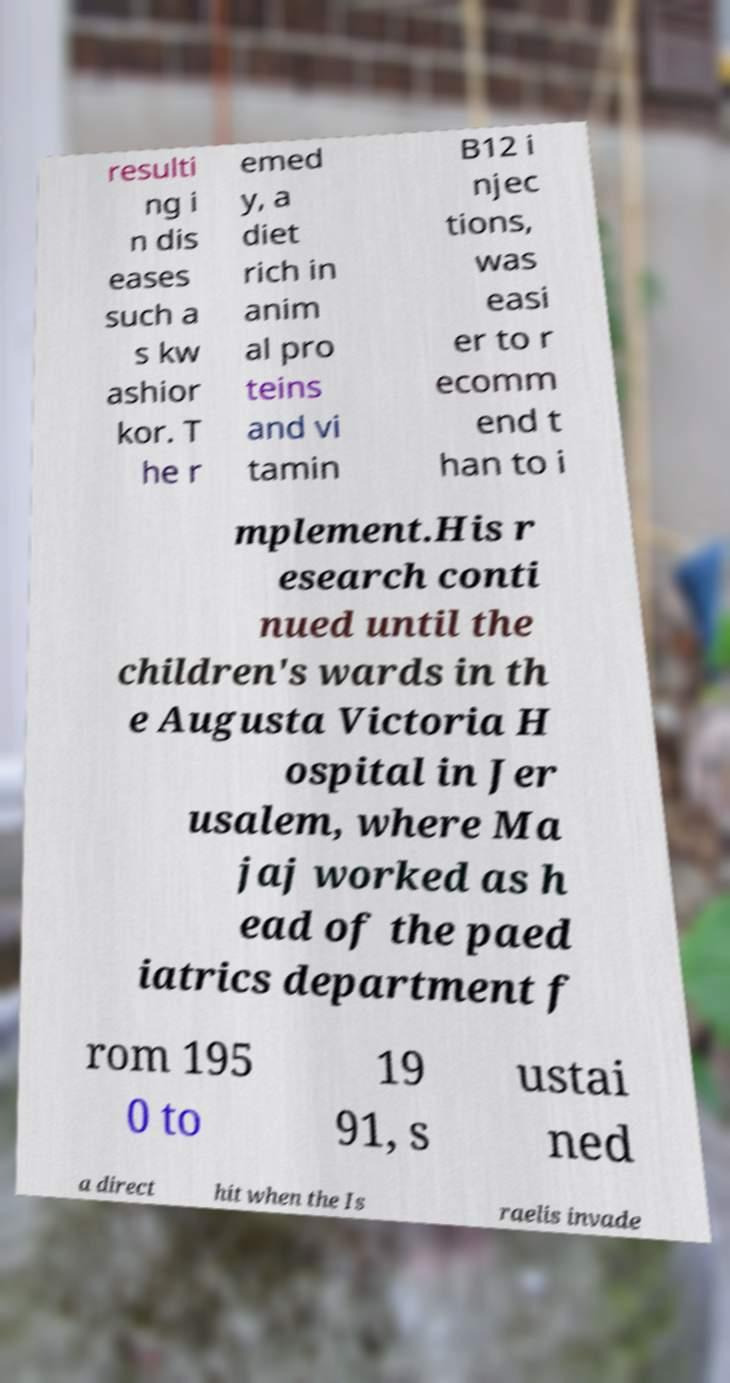Can you accurately transcribe the text from the provided image for me? resulti ng i n dis eases such a s kw ashior kor. T he r emed y, a diet rich in anim al pro teins and vi tamin B12 i njec tions, was easi er to r ecomm end t han to i mplement.His r esearch conti nued until the children's wards in th e Augusta Victoria H ospital in Jer usalem, where Ma jaj worked as h ead of the paed iatrics department f rom 195 0 to 19 91, s ustai ned a direct hit when the Is raelis invade 